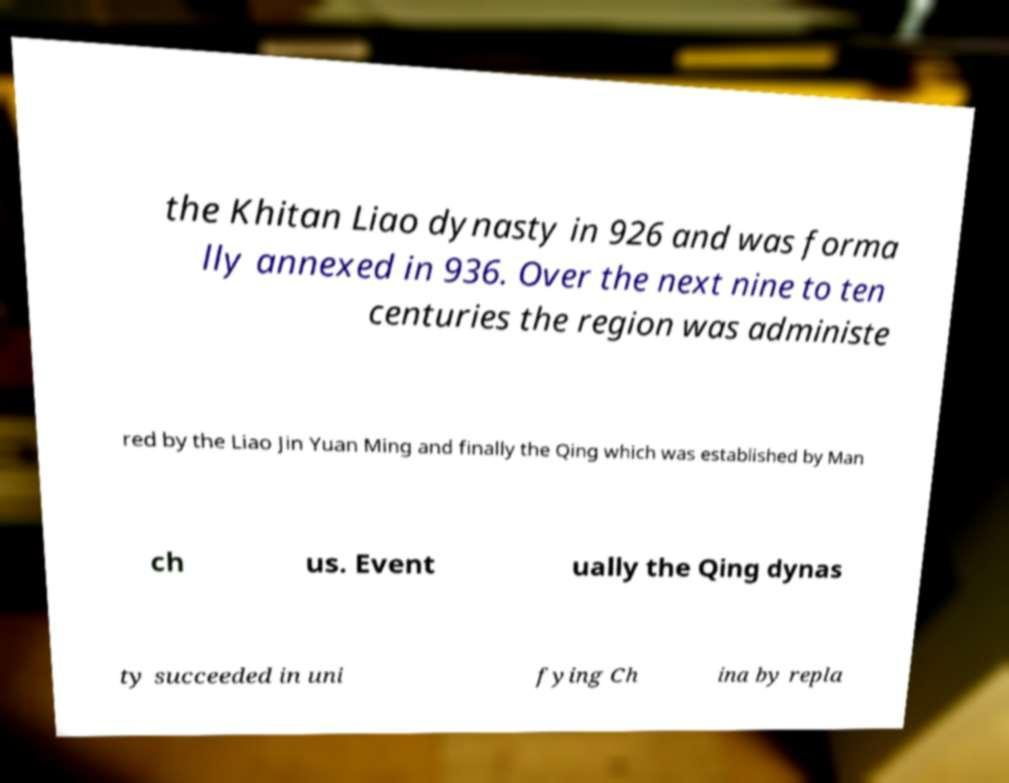Can you read and provide the text displayed in the image?This photo seems to have some interesting text. Can you extract and type it out for me? the Khitan Liao dynasty in 926 and was forma lly annexed in 936. Over the next nine to ten centuries the region was administe red by the Liao Jin Yuan Ming and finally the Qing which was established by Man ch us. Event ually the Qing dynas ty succeeded in uni fying Ch ina by repla 